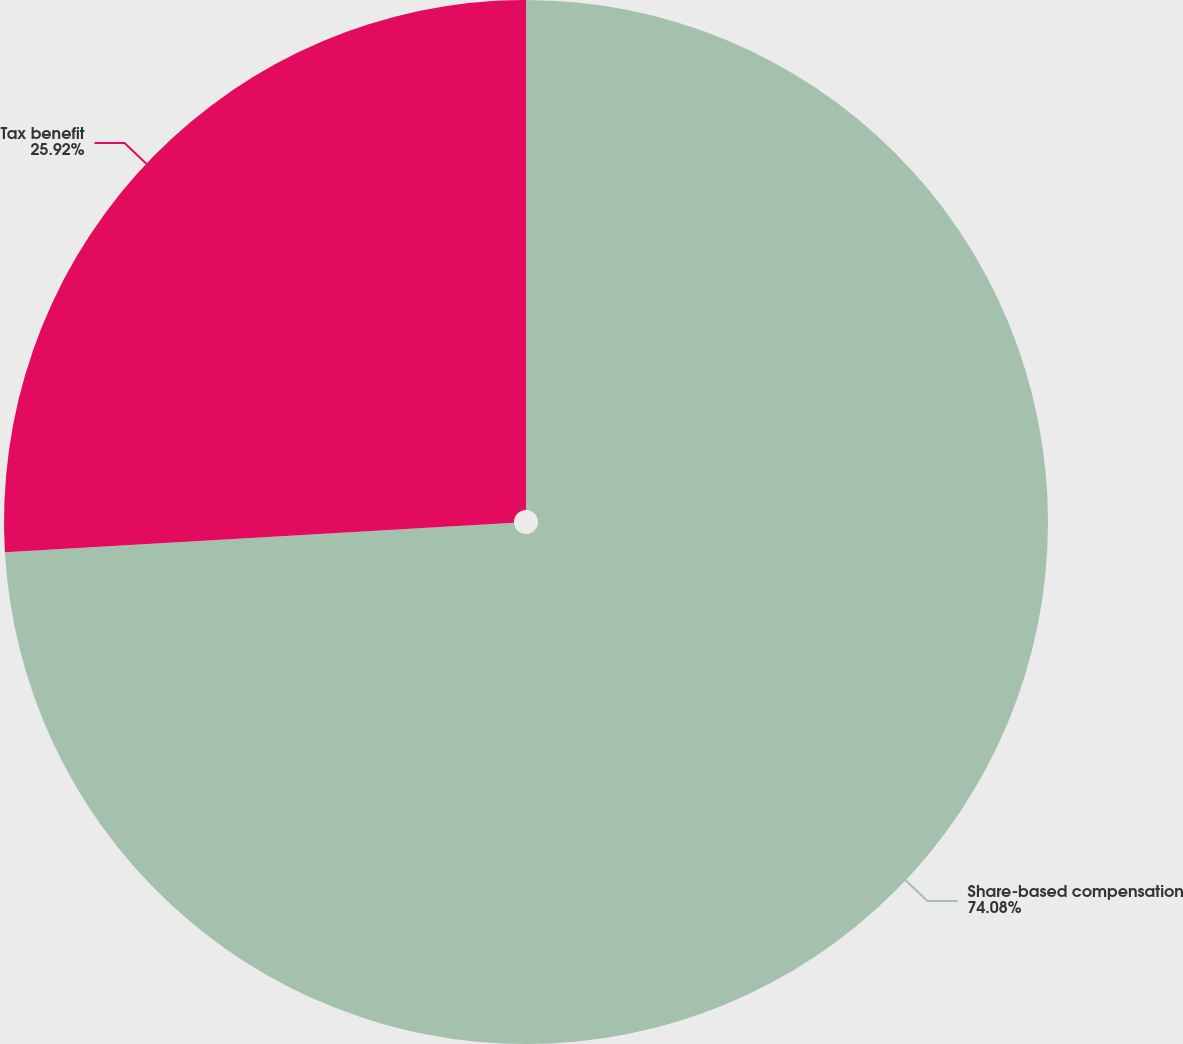Convert chart to OTSL. <chart><loc_0><loc_0><loc_500><loc_500><pie_chart><fcel>Share-based compensation<fcel>Tax benefit<nl><fcel>74.08%<fcel>25.92%<nl></chart> 